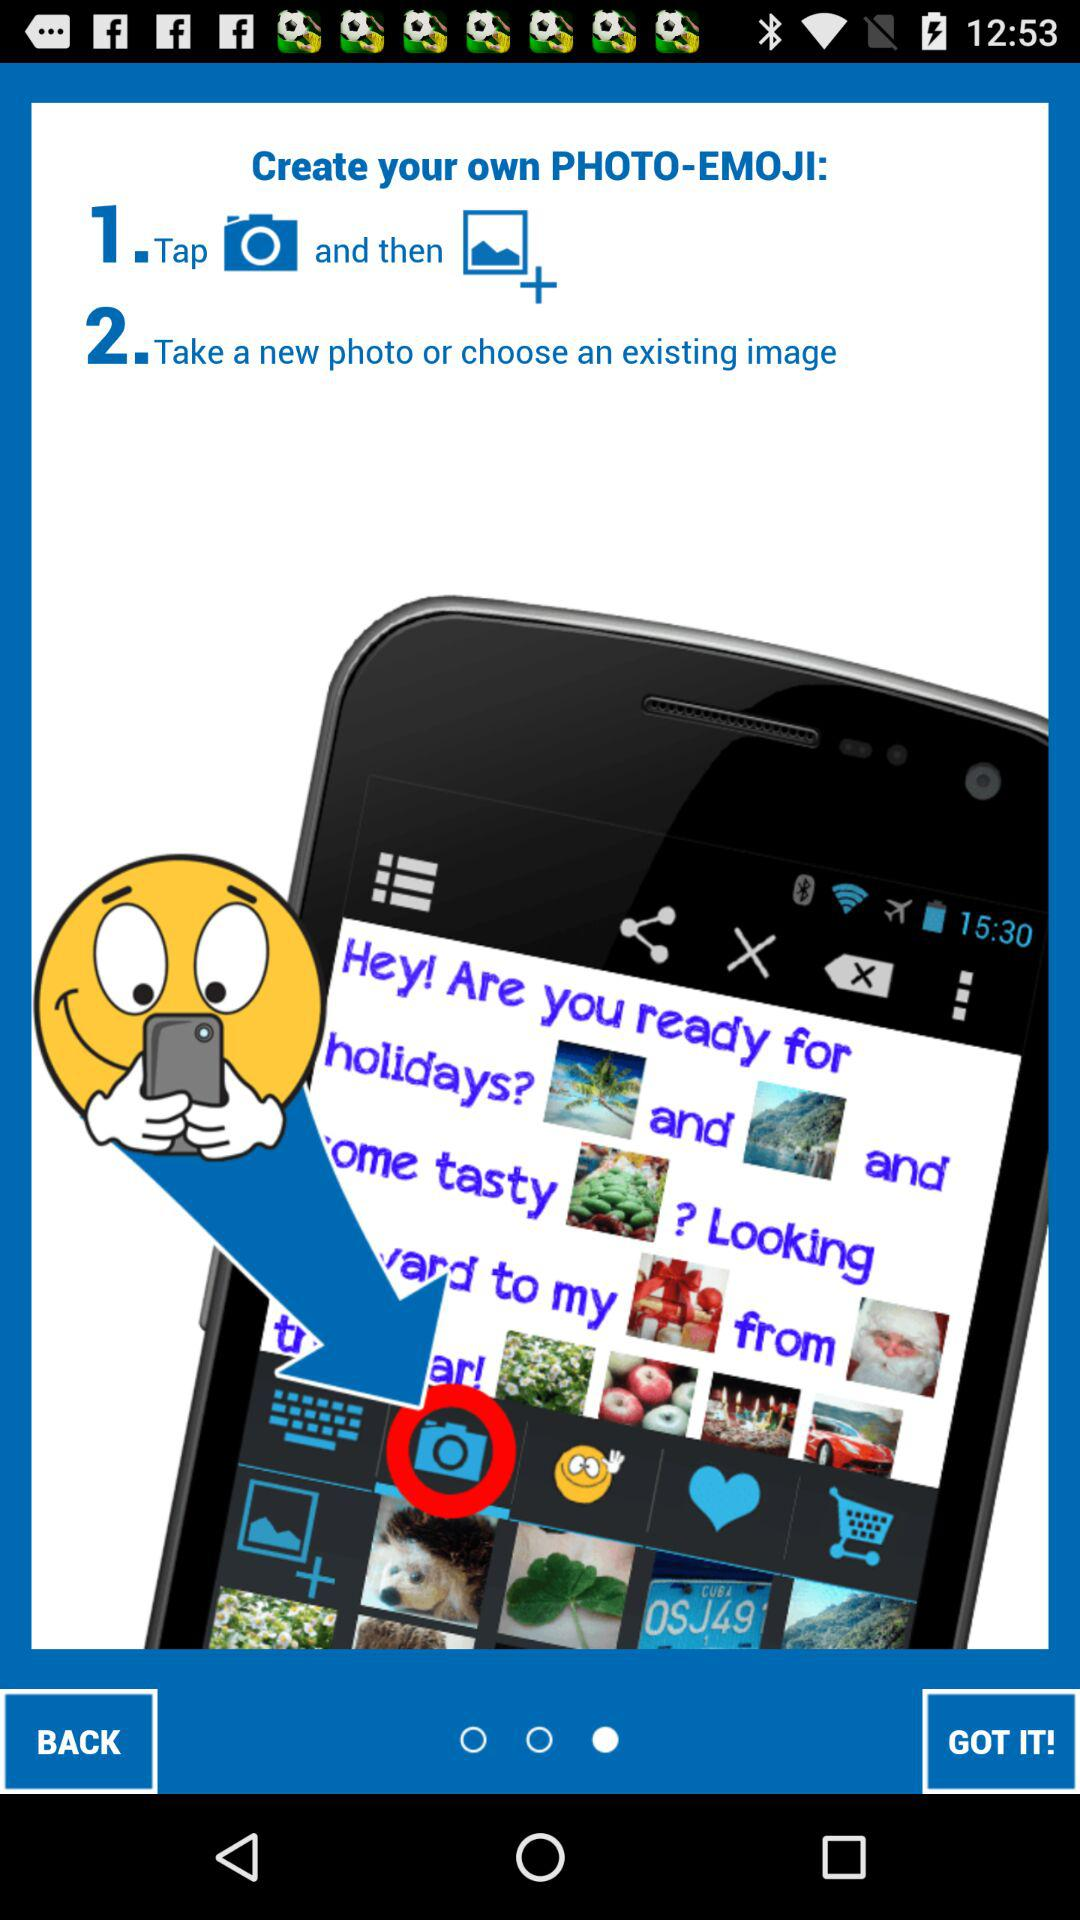How many steps are there in the process of creating a photo-emoji?
Answer the question using a single word or phrase. 2 